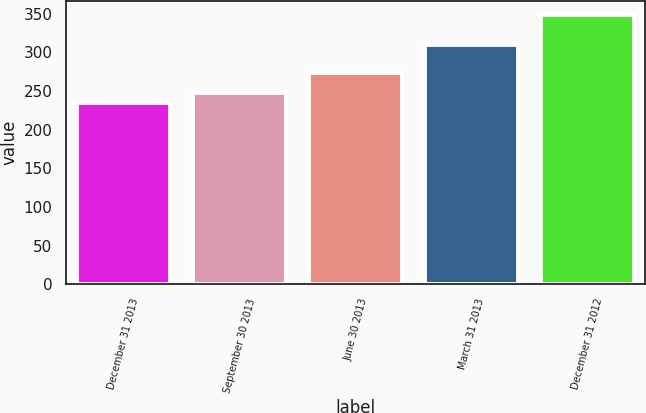Convert chart to OTSL. <chart><loc_0><loc_0><loc_500><loc_500><bar_chart><fcel>December 31 2013<fcel>September 30 2013<fcel>June 30 2013<fcel>March 31 2013<fcel>December 31 2012<nl><fcel>234.7<fcel>247<fcel>272.8<fcel>310<fcel>348.7<nl></chart> 